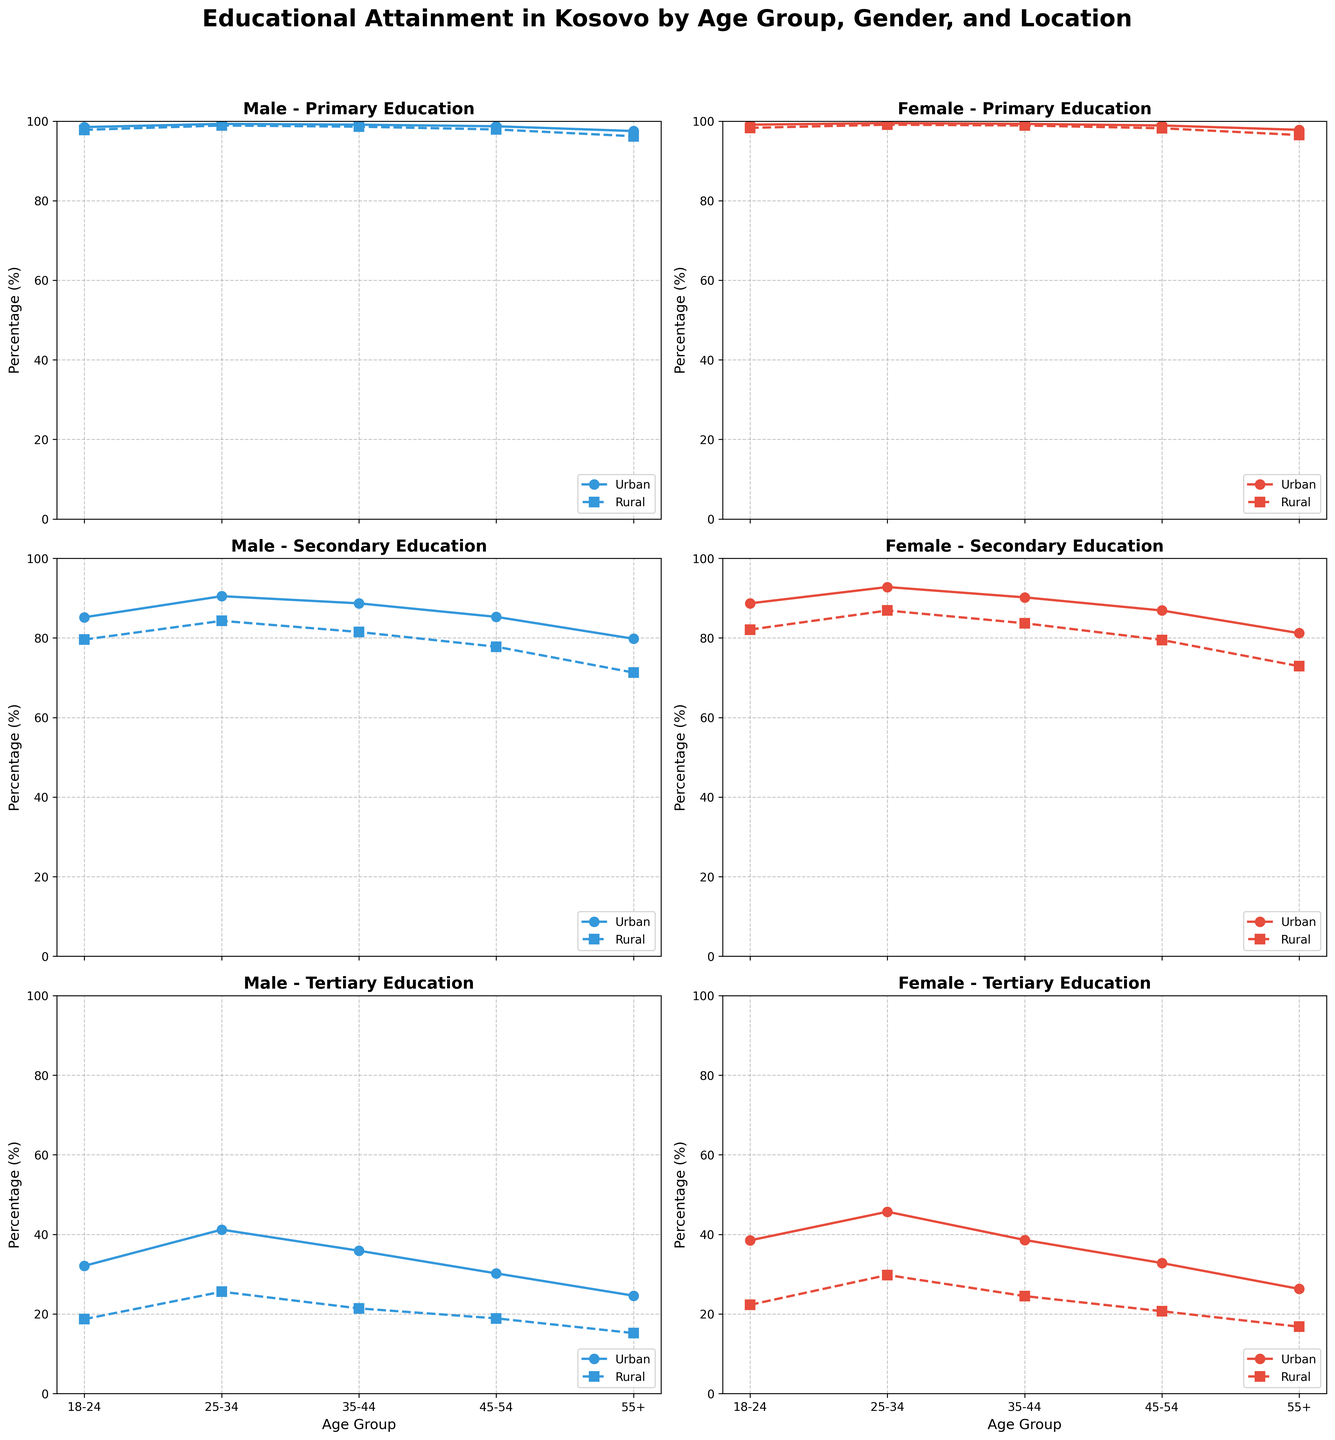What is the title of the figure? The title is located at the top of the figure, and it provides an overview of what the figure shows.
Answer: Educational Attainment in Kosovo by Age Group, Gender, and Location Which gender has higher tertiary education in rural areas for the age group 25-34? Look at the tertiary education subplot for the age group 25-34. Compare the male and female lines for rural areas.
Answer: Female What is the highest reported percentage of primary education in urban areas and which group does it belong to? Identify the subplot focusing on primary education. Look for the highest data point in the urban area lines across all age groups and genders.
Answer: Female, 25-34 How does the secondary education attainment in rural areas compare between males and females in the age group 18-24? Go to the secondary education subplot and locate the data points for the age group 18-24. Compare the percentages for males and females in rural areas by identifying their respective lines.
Answer: Female has higher secondary education than male in rural areas (82.1% vs 79.6%) In which age group do urban males have the highest percentage of tertiary education? Focus on the tertiary education subplots. Trace the urban males' line (solid line with circles) across all age groups and find the highest point.
Answer: 25-34 Compare the tertiary education attainment levels between urban and rural females for the age group 35-44. Look at the tertiary education subplot for females. Identify the data points for urban and rural females in the 35-44 age group and compare the percentages.
Answer: Urban (38.6%) is higher than rural (24.5%) What age group shows the largest gap in secondary education attainment between urban and rural females? Examine secondary education subplots focusing on females across different age groups. Calculate the gap by subtracting rural percentages from urban percentages for each age group and identify the largest difference.
Answer: 25-34 (92.8% - 86.9% = 5.9%) Is there a noticeable trend in primary education percentages across age groups for urban males? Observe the primary education subplot and trace the line for urban males across all age groups. Identify if there are any increasing or decreasing trends.
Answer: No noticeable trend, all percentages are very close For the age group 55+, compare the primary and secondary education percentages between urban and rural males. Locate the primary and secondary education subplots for males. Identify the data points for urban and rural males in the 55+ age group and compare their percentages.
Answer: Urban primary: 97.5%, rural primary: 96.2%; Urban secondary: 79.8%, rural secondary: 71.3% What is the trend in tertiary education for females from age group 18-24 to 45-54 in urban areas? Follow the tertiary education subplot for females, noting the data points for urban areas from age group 18-24 to 45-54 to identify any upward or downward trend.
Answer: Slight decreasing trend (38.5% to 32.8%) 